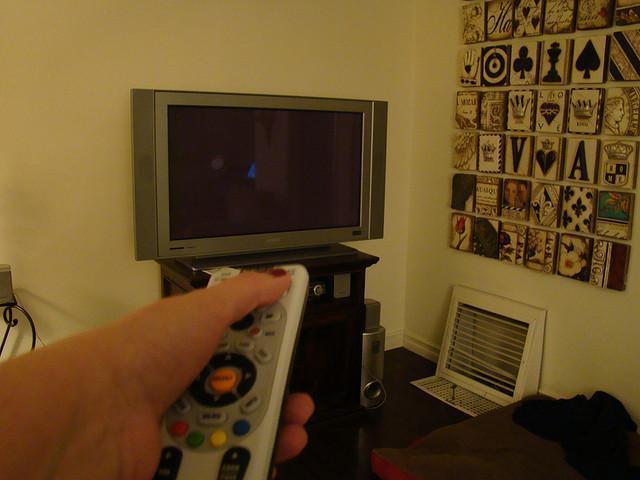How many bowls contain red foods?
Give a very brief answer. 0. 